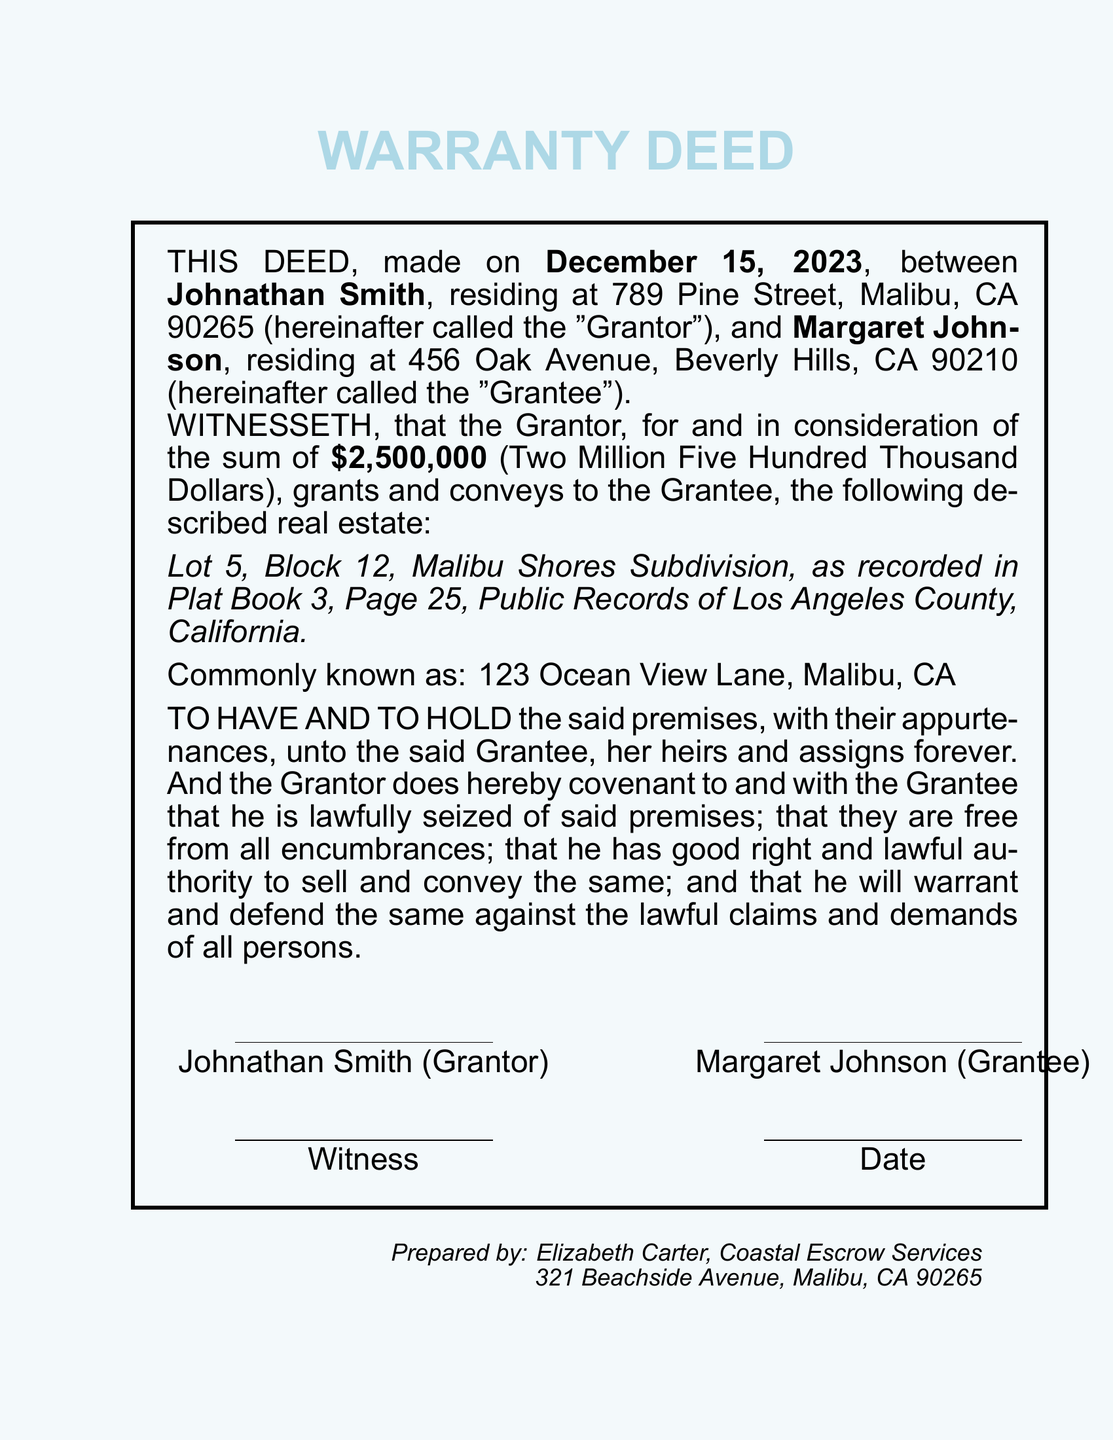What is the date of the deed? The date of the deed is specifically mentioned in the document as December 15, 2023.
Answer: December 15, 2023 Who is the Grantor? The Grantor's name is provided in the document as Johnathan Smith.
Answer: Johnathan Smith What is the purchase price? The purchase price is detailed in the document as Two Million Five Hundred Thousand Dollars.
Answer: Two Million Five Hundred Thousand Dollars What is the common address of the property? The common address of the property is listed in the document as 123 Ocean View Lane, Malibu, CA.
Answer: 123 Ocean View Lane, Malibu, CA Who prepared the deed? The document states that it was prepared by Elizabeth Carter.
Answer: Elizabeth Carter What is the number of the Lot? The lot number is described in the document as Lot 5.
Answer: Lot 5 What type of deed is this? The document identifies itself as a Warranty Deed.
Answer: Warranty Deed What is the name of the Grantee? The Grantee's name is specified as Margaret Johnson in the document.
Answer: Margaret Johnson What does the Grantor guarantee about the property? The Grantor guarantees that the property is free from all encumbrances and lawful to sell.
Answer: Free from all encumbrances 